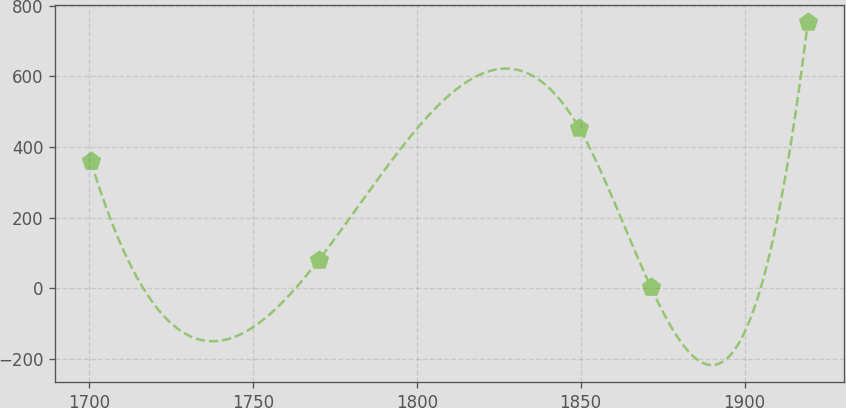Convert chart. <chart><loc_0><loc_0><loc_500><loc_500><line_chart><ecel><fcel>Unnamed: 1<nl><fcel>1700.63<fcel>359.59<nl><fcel>1770.09<fcel>79.54<nl><fcel>1849.45<fcel>455<nl><fcel>1871.31<fcel>4.67<nl><fcel>1919.26<fcel>753.37<nl></chart> 